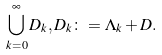<formula> <loc_0><loc_0><loc_500><loc_500>\bigcup _ { k = 0 } ^ { \infty } D _ { k } , D _ { k } \colon = \Lambda _ { k } + D .</formula> 